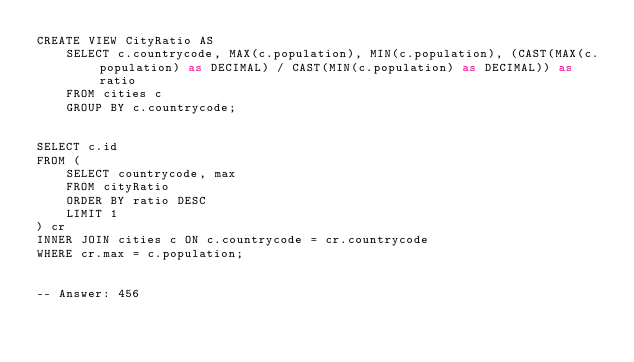<code> <loc_0><loc_0><loc_500><loc_500><_SQL_>CREATE VIEW CityRatio AS
    SELECT c.countrycode, MAX(c.population), MIN(c.population), (CAST(MAX(c.population) as DECIMAL) / CAST(MIN(c.population) as DECIMAL)) as ratio
    FROM cities c
    GROUP BY c.countrycode;


SELECT c.id
FROM (
    SELECT countrycode, max
    FROM cityRatio
    ORDER BY ratio DESC
    LIMIT 1
) cr
INNER JOIN cities c ON c.countrycode = cr.countrycode
WHERE cr.max = c.population;


-- Answer: 456</code> 